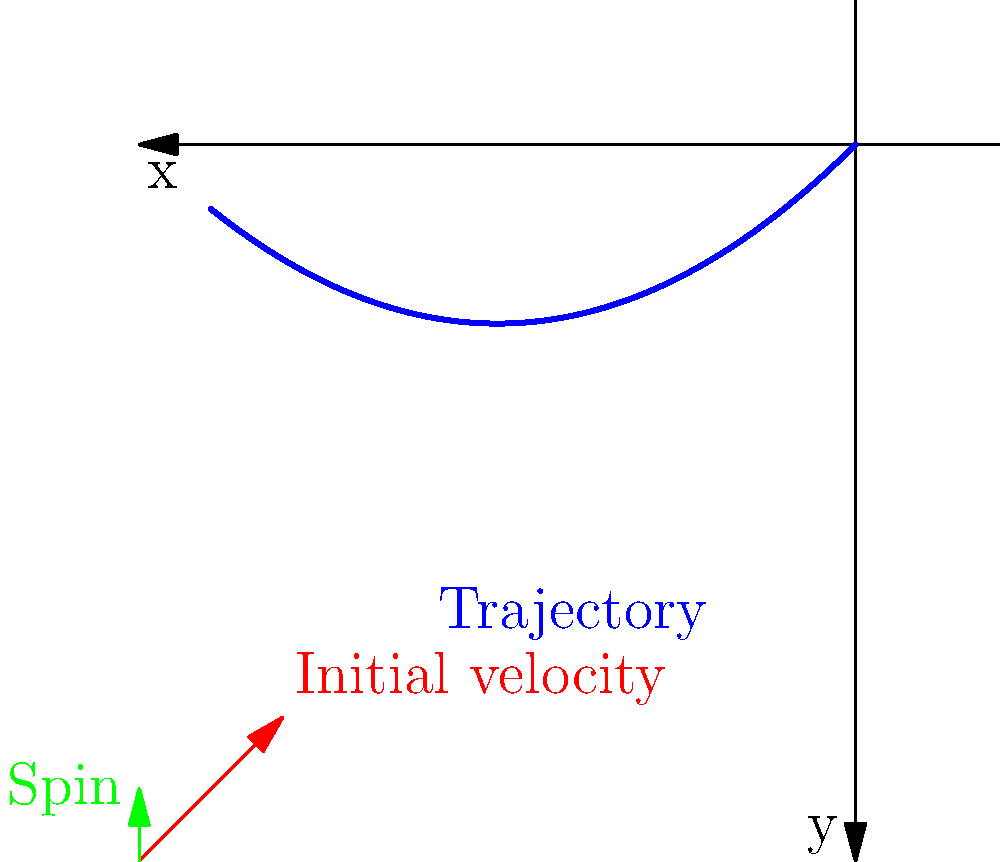Given a soccer ball's initial velocity vector of $\vec{v_0} = (10\text{ m/s}, 10\text{ m/s})$ and a spin vector of $\vec{\omega} = (0, 5\text{ rad/s}, 0)$, how would you use machine learning to predict the ball's trajectory? Consider factors such as air resistance and the Magnus effect. To predict the soccer ball's trajectory using machine learning, we can follow these steps:

1. Data Collection:
   - Gather historical data on soccer ball trajectories with various initial conditions.
   - Include features such as initial velocity, spin, air density, and wind speed.

2. Feature Engineering:
   - Create relevant features like the magnitude of initial velocity: $|\vec{v_0}| = \sqrt{v_x^2 + v_y^2}$.
   - Calculate the angle of the initial velocity: $\theta = \tan^{-1}(v_y/v_x)$.
   - Compute the cross product of velocity and spin: $\vec{v_0} \times \vec{\omega}$.

3. Model Selection:
   - Choose a suitable ML model, such as a neural network or random forest.
   - The model should be able to capture non-linear relationships due to air resistance and the Magnus effect.

4. Training:
   - Split the data into training and testing sets.
   - Train the model using the training data, with input features including initial velocity, spin, and environmental factors.
   - The output should be a series of (x, y) coordinates representing the ball's trajectory.

5. Model Evaluation:
   - Use the testing set to evaluate the model's performance.
   - Metrics could include mean squared error of predicted vs. actual positions.

6. Physical Constraints:
   - Incorporate physical laws as constraints or loss terms in the model.
   - For example, ensure the predicted trajectory follows a parabolic shape due to gravity.

7. Magnus Effect Consideration:
   - The Magnus effect causes a force perpendicular to the velocity and spin axis:
     $\vec{F_M} = \frac{1}{2}\rho A C_L (\vec{\omega} \times \vec{v})$
   where $\rho$ is air density, $A$ is the ball's cross-sectional area, and $C_L$ is the lift coefficient.

8. Air Resistance:
   - Include air resistance as a force opposing motion:
     $\vec{F_D} = -\frac{1}{2}\rho A C_D |\vec{v}|^2 \hat{v}$
   where $C_D$ is the drag coefficient and $\hat{v}$ is the unit vector in the velocity direction.

9. Prediction:
   - Use the trained model to predict the trajectory given new initial conditions.
   - The model should output a series of (x, y) coordinates representing the ball's path.

10. Refinement:
    - Continuously update the model with new data to improve accuracy.
    - Consider ensemble methods or more advanced techniques like physics-informed neural networks for better results.
Answer: Neural network trained on historical trajectory data, incorporating physical constraints and effects like Magnus force and air resistance. 